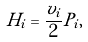Convert formula to latex. <formula><loc_0><loc_0><loc_500><loc_500>H _ { i } = \frac { v _ { i } } { 2 } P _ { i } ,</formula> 